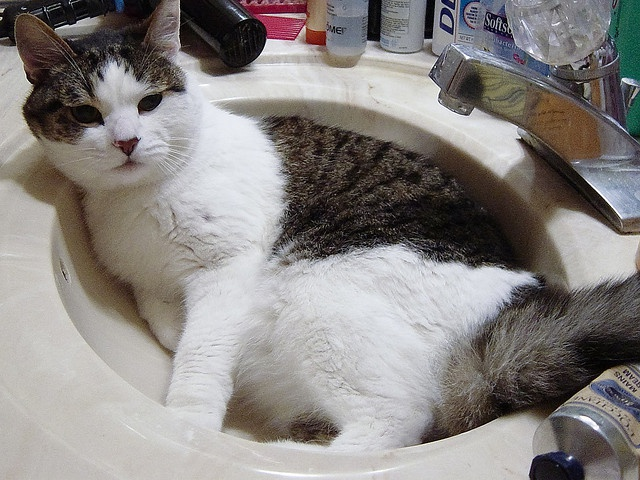Describe the objects in this image and their specific colors. I can see cat in gray, lightgray, black, and darkgray tones, sink in gray, lightgray, and darkgray tones, bottle in gray, darkgray, and black tones, bottle in gray tones, and bottle in gray tones in this image. 